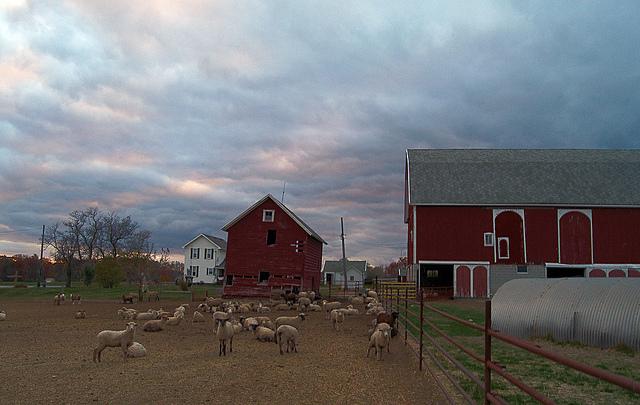How many barns can be seen?
Write a very short answer. 2. How many animals are in the picture?
Keep it brief. 30. How many sheep are present?
Answer briefly. 20. Why is there orange color in the clouds?
Give a very brief answer. Sunset. 